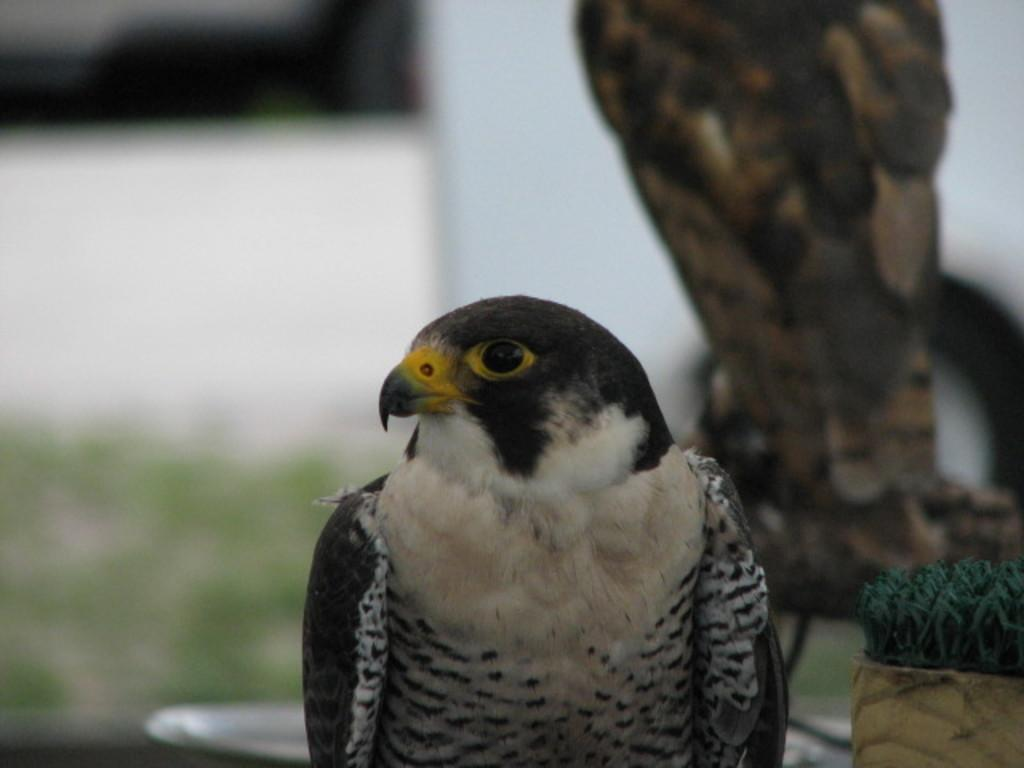What type of animal is present in the image? There is a bird in the image. Can you describe the colors of the bird? The bird has white, black, and yellow colors. How would you describe the background of the image? The background of the image is blurred. What type of brake can be seen on the bird in the image? There is no brake present on the bird in the image. What type of coat is the bird wearing in the image? Birds do not wear coats, so this question cannot be answered definitively from the image. 